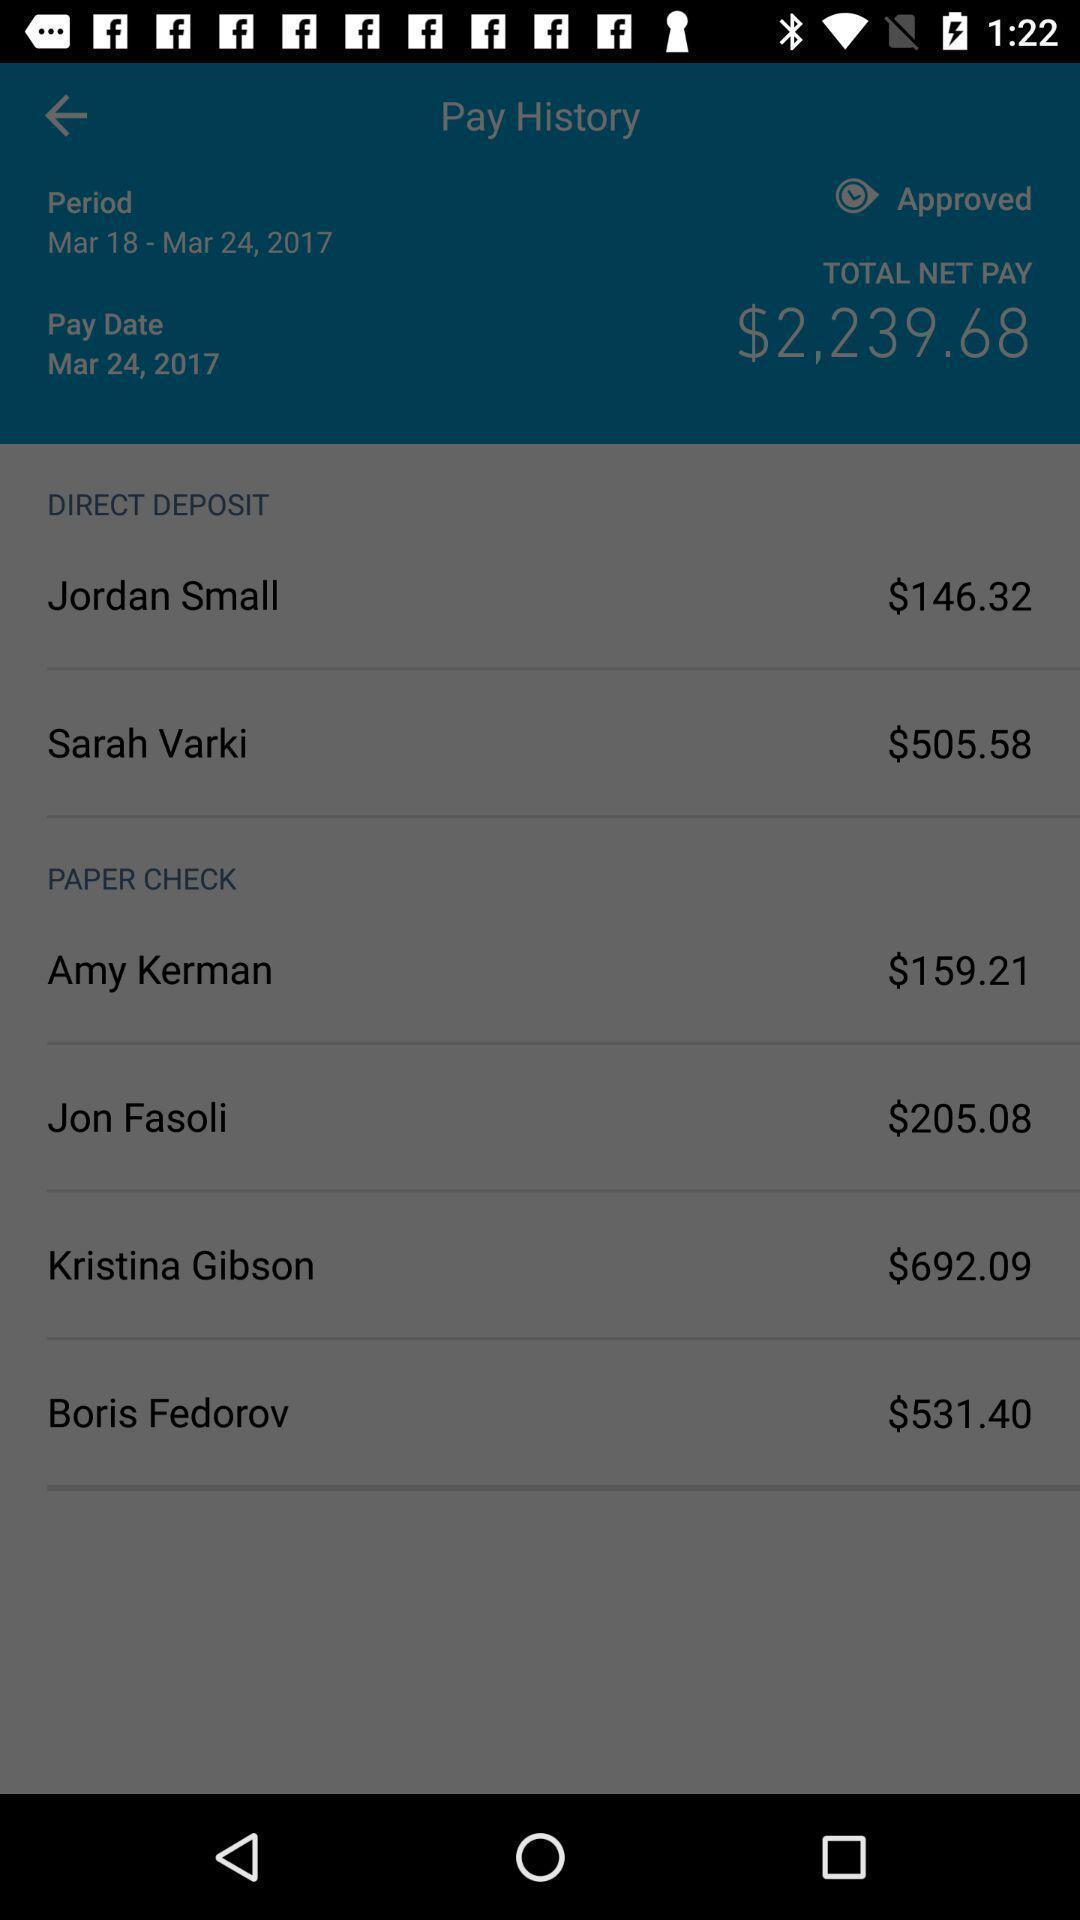Summarize the main components in this picture. Page showing your pay history in the money app. 